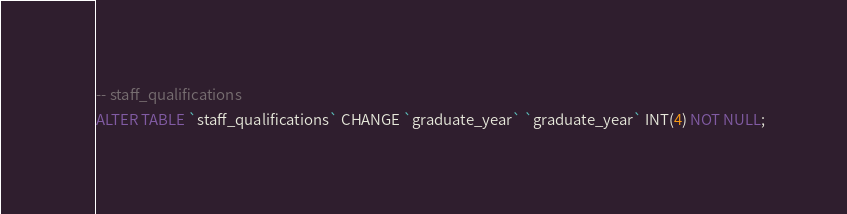Convert code to text. <code><loc_0><loc_0><loc_500><loc_500><_SQL_>-- staff_qualifications
ALTER TABLE `staff_qualifications` CHANGE `graduate_year` `graduate_year` INT(4) NOT NULL;</code> 